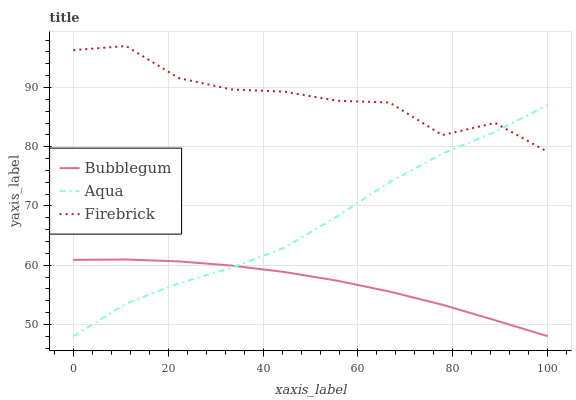Does Bubblegum have the minimum area under the curve?
Answer yes or no. Yes. Does Firebrick have the maximum area under the curve?
Answer yes or no. Yes. Does Aqua have the minimum area under the curve?
Answer yes or no. No. Does Aqua have the maximum area under the curve?
Answer yes or no. No. Is Bubblegum the smoothest?
Answer yes or no. Yes. Is Firebrick the roughest?
Answer yes or no. Yes. Is Aqua the smoothest?
Answer yes or no. No. Is Aqua the roughest?
Answer yes or no. No. Does Aqua have the lowest value?
Answer yes or no. Yes. Does Firebrick have the highest value?
Answer yes or no. Yes. Does Aqua have the highest value?
Answer yes or no. No. Is Bubblegum less than Firebrick?
Answer yes or no. Yes. Is Firebrick greater than Bubblegum?
Answer yes or no. Yes. Does Aqua intersect Firebrick?
Answer yes or no. Yes. Is Aqua less than Firebrick?
Answer yes or no. No. Is Aqua greater than Firebrick?
Answer yes or no. No. Does Bubblegum intersect Firebrick?
Answer yes or no. No. 